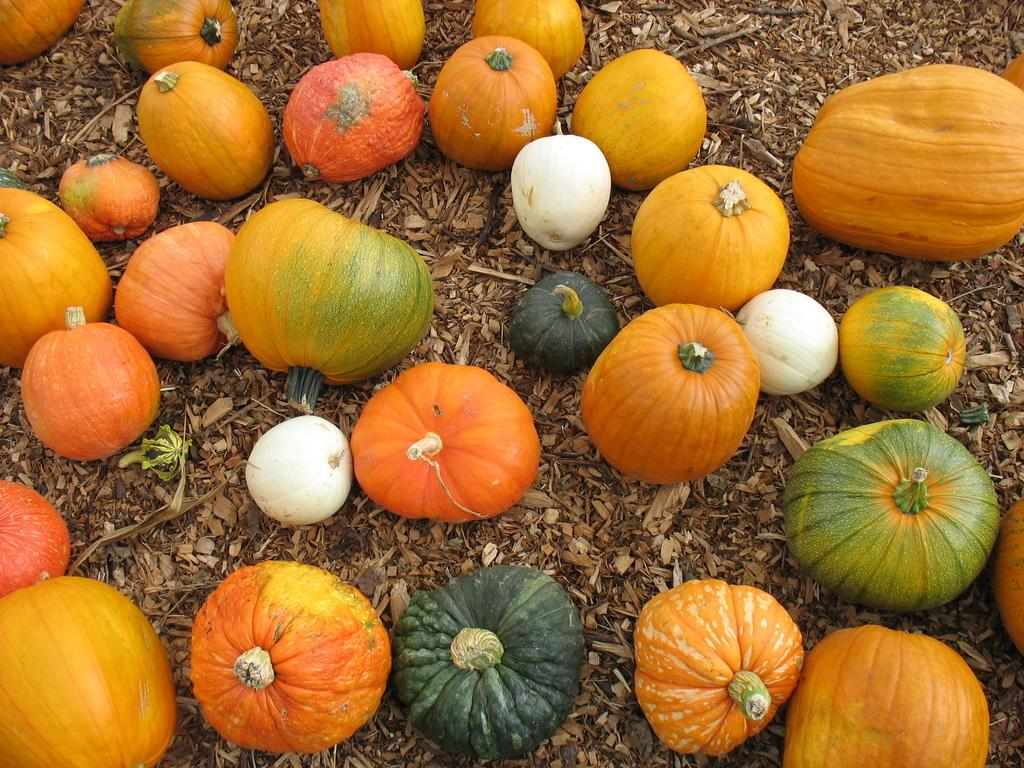What type of vegetables are present in the image? There are cucumbers and pumpkins in the image. How are the cucumbers and pumpkins arranged? The cucumbers and pumpkins are arranged on the ground. What other objects can be seen in the image? There are wooden pieces and sticks in the image. Can you tell me how many toes are visible in the image? There are no toes visible in the image; it features cucumbers, pumpkins, wooden pieces, and sticks. 